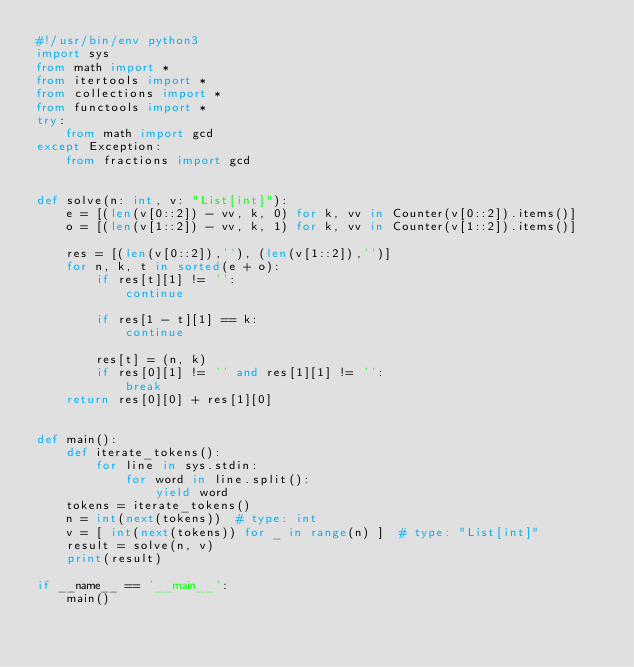Convert code to text. <code><loc_0><loc_0><loc_500><loc_500><_Python_>#!/usr/bin/env python3
import sys
from math import *
from itertools import *
from collections import *
from functools import *
try:
    from math import gcd
except Exception:
    from fractions import gcd


def solve(n: int, v: "List[int]"):
    e = [(len(v[0::2]) - vv, k, 0) for k, vv in Counter(v[0::2]).items()]
    o = [(len(v[1::2]) - vv, k, 1) for k, vv in Counter(v[1::2]).items()]

    res = [(len(v[0::2]),''), (len(v[1::2]),'')]
    for n, k, t in sorted(e + o):
        if res[t][1] != '':
            continue

        if res[1 - t][1] == k:
            continue

        res[t] = (n, k)
        if res[0][1] != '' and res[1][1] != '':
            break
    return res[0][0] + res[1][0]


def main():
    def iterate_tokens():
        for line in sys.stdin:
            for word in line.split():
                yield word
    tokens = iterate_tokens()
    n = int(next(tokens))  # type: int
    v = [ int(next(tokens)) for _ in range(n) ]  # type: "List[int]"
    result = solve(n, v)
    print(result)

if __name__ == '__main__':
    main()
</code> 